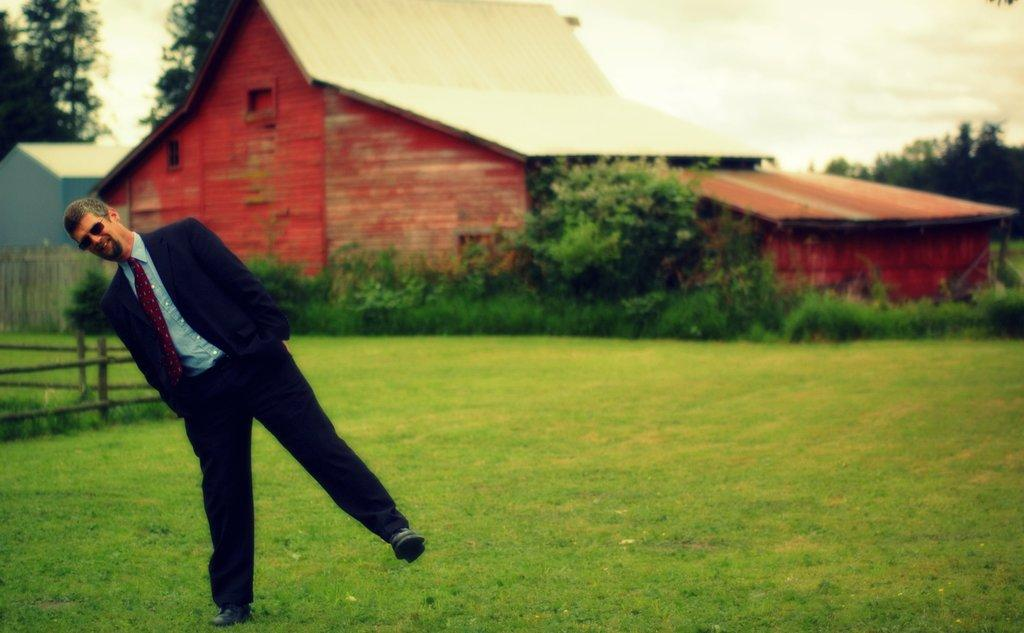What is the man in the image wearing? The man is wearing shades, a tie, a shirt, and a suit. What can be seen in the background of the image? There is a house, trees, grass, and the sky visible in the background of the image. What type of plantation is visible in the background of the image? There is no plantation visible in the background of the image; it features a house, trees, grass, and the sky. What government policy is the man in the image advocating for? There is no indication of any government policy or advocacy in the image; it simply shows a man wearing a suit and standing in front of a background with a house, trees, grass, and the sky. 